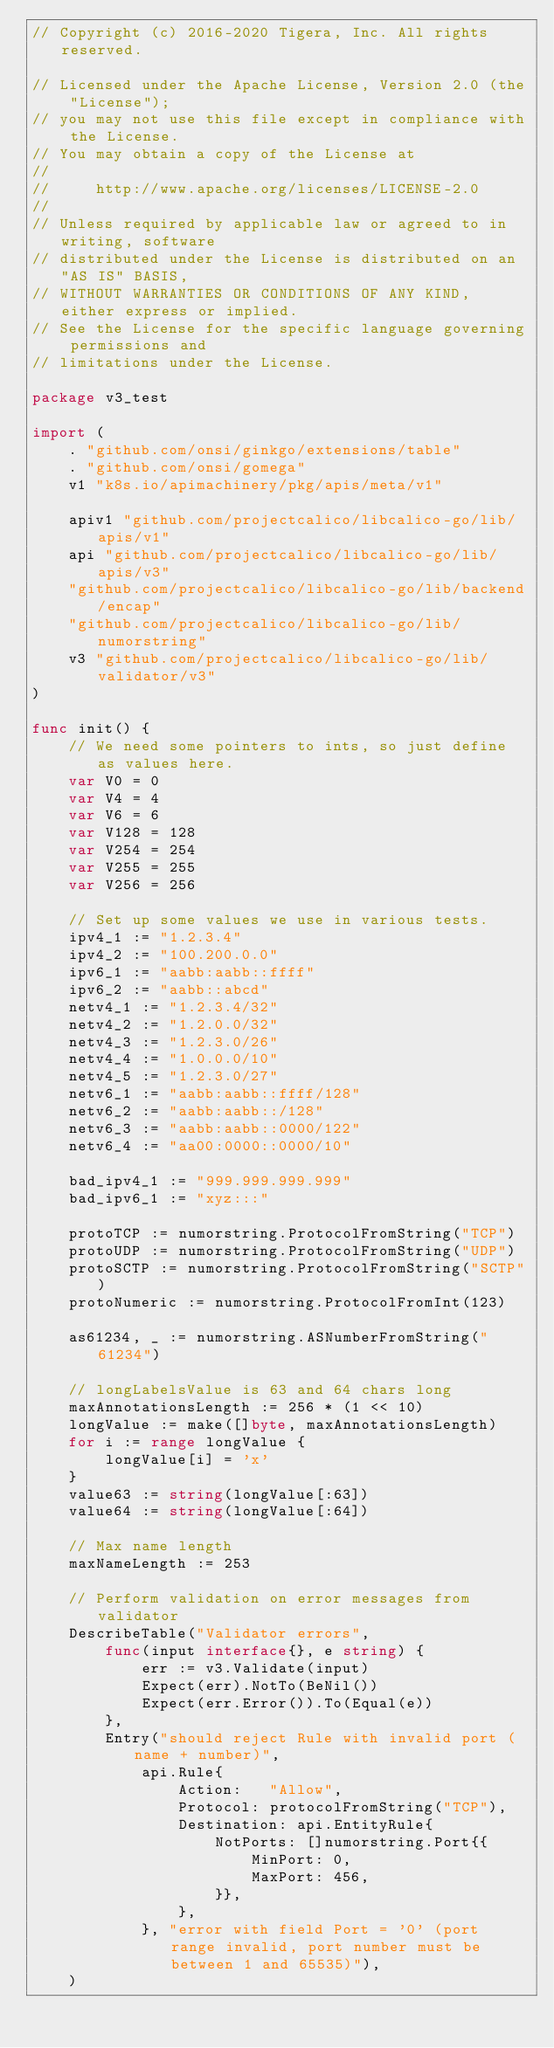Convert code to text. <code><loc_0><loc_0><loc_500><loc_500><_Go_>// Copyright (c) 2016-2020 Tigera, Inc. All rights reserved.

// Licensed under the Apache License, Version 2.0 (the "License");
// you may not use this file except in compliance with the License.
// You may obtain a copy of the License at
//
//     http://www.apache.org/licenses/LICENSE-2.0
//
// Unless required by applicable law or agreed to in writing, software
// distributed under the License is distributed on an "AS IS" BASIS,
// WITHOUT WARRANTIES OR CONDITIONS OF ANY KIND, either express or implied.
// See the License for the specific language governing permissions and
// limitations under the License.

package v3_test

import (
	. "github.com/onsi/ginkgo/extensions/table"
	. "github.com/onsi/gomega"
	v1 "k8s.io/apimachinery/pkg/apis/meta/v1"

	apiv1 "github.com/projectcalico/libcalico-go/lib/apis/v1"
	api "github.com/projectcalico/libcalico-go/lib/apis/v3"
	"github.com/projectcalico/libcalico-go/lib/backend/encap"
	"github.com/projectcalico/libcalico-go/lib/numorstring"
	v3 "github.com/projectcalico/libcalico-go/lib/validator/v3"
)

func init() {
	// We need some pointers to ints, so just define as values here.
	var V0 = 0
	var V4 = 4
	var V6 = 6
	var V128 = 128
	var V254 = 254
	var V255 = 255
	var V256 = 256

	// Set up some values we use in various tests.
	ipv4_1 := "1.2.3.4"
	ipv4_2 := "100.200.0.0"
	ipv6_1 := "aabb:aabb::ffff"
	ipv6_2 := "aabb::abcd"
	netv4_1 := "1.2.3.4/32"
	netv4_2 := "1.2.0.0/32"
	netv4_3 := "1.2.3.0/26"
	netv4_4 := "1.0.0.0/10"
	netv4_5 := "1.2.3.0/27"
	netv6_1 := "aabb:aabb::ffff/128"
	netv6_2 := "aabb:aabb::/128"
	netv6_3 := "aabb:aabb::0000/122"
	netv6_4 := "aa00:0000::0000/10"

	bad_ipv4_1 := "999.999.999.999"
	bad_ipv6_1 := "xyz:::"

	protoTCP := numorstring.ProtocolFromString("TCP")
	protoUDP := numorstring.ProtocolFromString("UDP")
	protoSCTP := numorstring.ProtocolFromString("SCTP")
	protoNumeric := numorstring.ProtocolFromInt(123)

	as61234, _ := numorstring.ASNumberFromString("61234")

	// longLabelsValue is 63 and 64 chars long
	maxAnnotationsLength := 256 * (1 << 10)
	longValue := make([]byte, maxAnnotationsLength)
	for i := range longValue {
		longValue[i] = 'x'
	}
	value63 := string(longValue[:63])
	value64 := string(longValue[:64])

	// Max name length
	maxNameLength := 253

	// Perform validation on error messages from validator
	DescribeTable("Validator errors",
		func(input interface{}, e string) {
			err := v3.Validate(input)
			Expect(err).NotTo(BeNil())
			Expect(err.Error()).To(Equal(e))
		},
		Entry("should reject Rule with invalid port (name + number)",
			api.Rule{
				Action:   "Allow",
				Protocol: protocolFromString("TCP"),
				Destination: api.EntityRule{
					NotPorts: []numorstring.Port{{
						MinPort: 0,
						MaxPort: 456,
					}},
				},
			}, "error with field Port = '0' (port range invalid, port number must be between 1 and 65535)"),
	)
</code> 